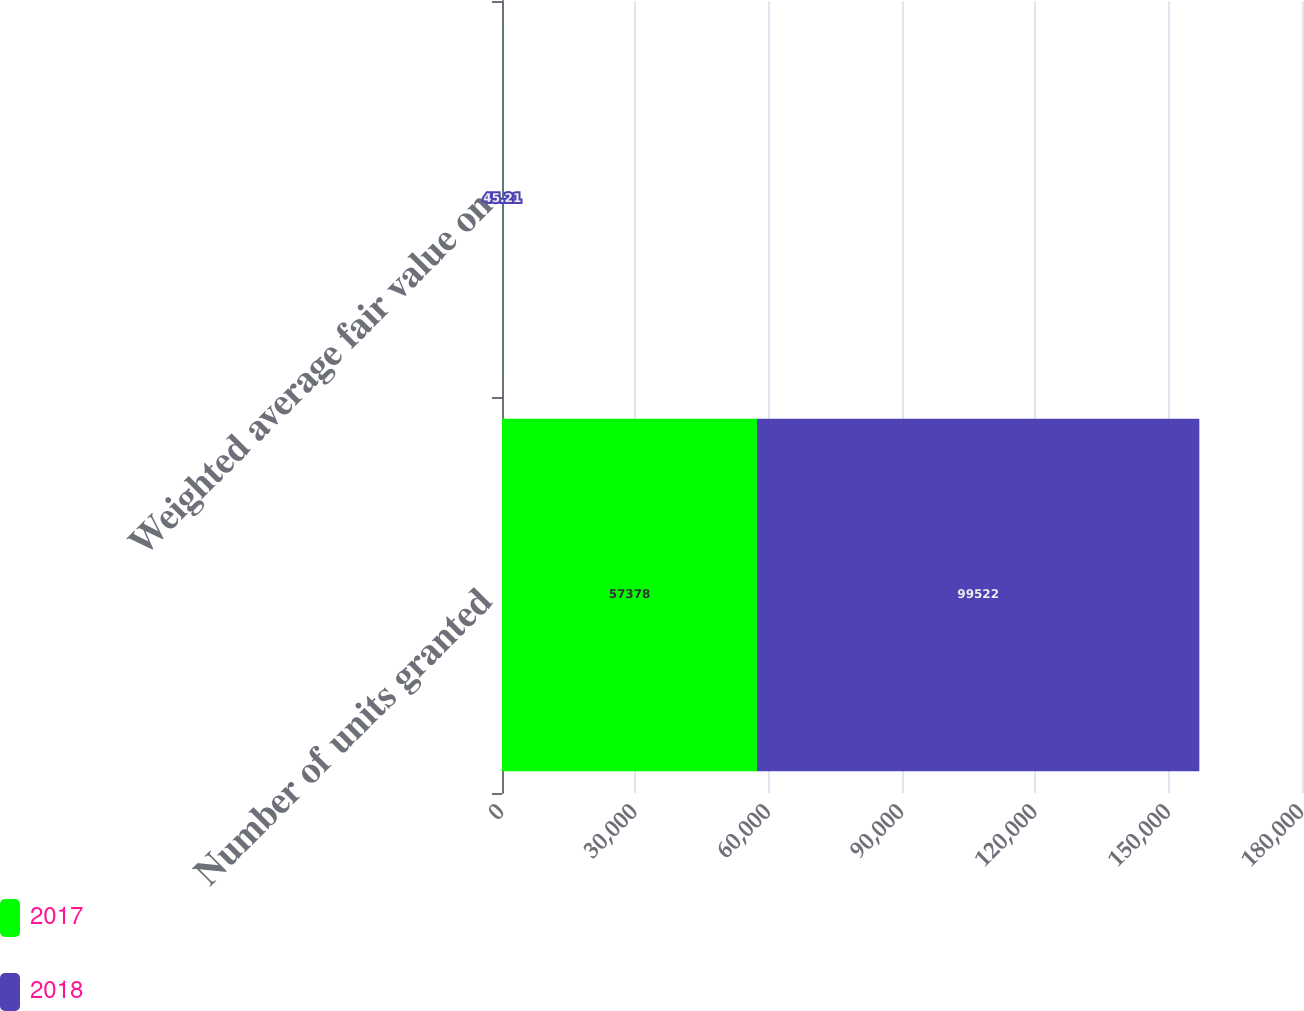Convert chart to OTSL. <chart><loc_0><loc_0><loc_500><loc_500><stacked_bar_chart><ecel><fcel>Number of units granted<fcel>Weighted average fair value on<nl><fcel>2017<fcel>57378<fcel>41.72<nl><fcel>2018<fcel>99522<fcel>45.21<nl></chart> 